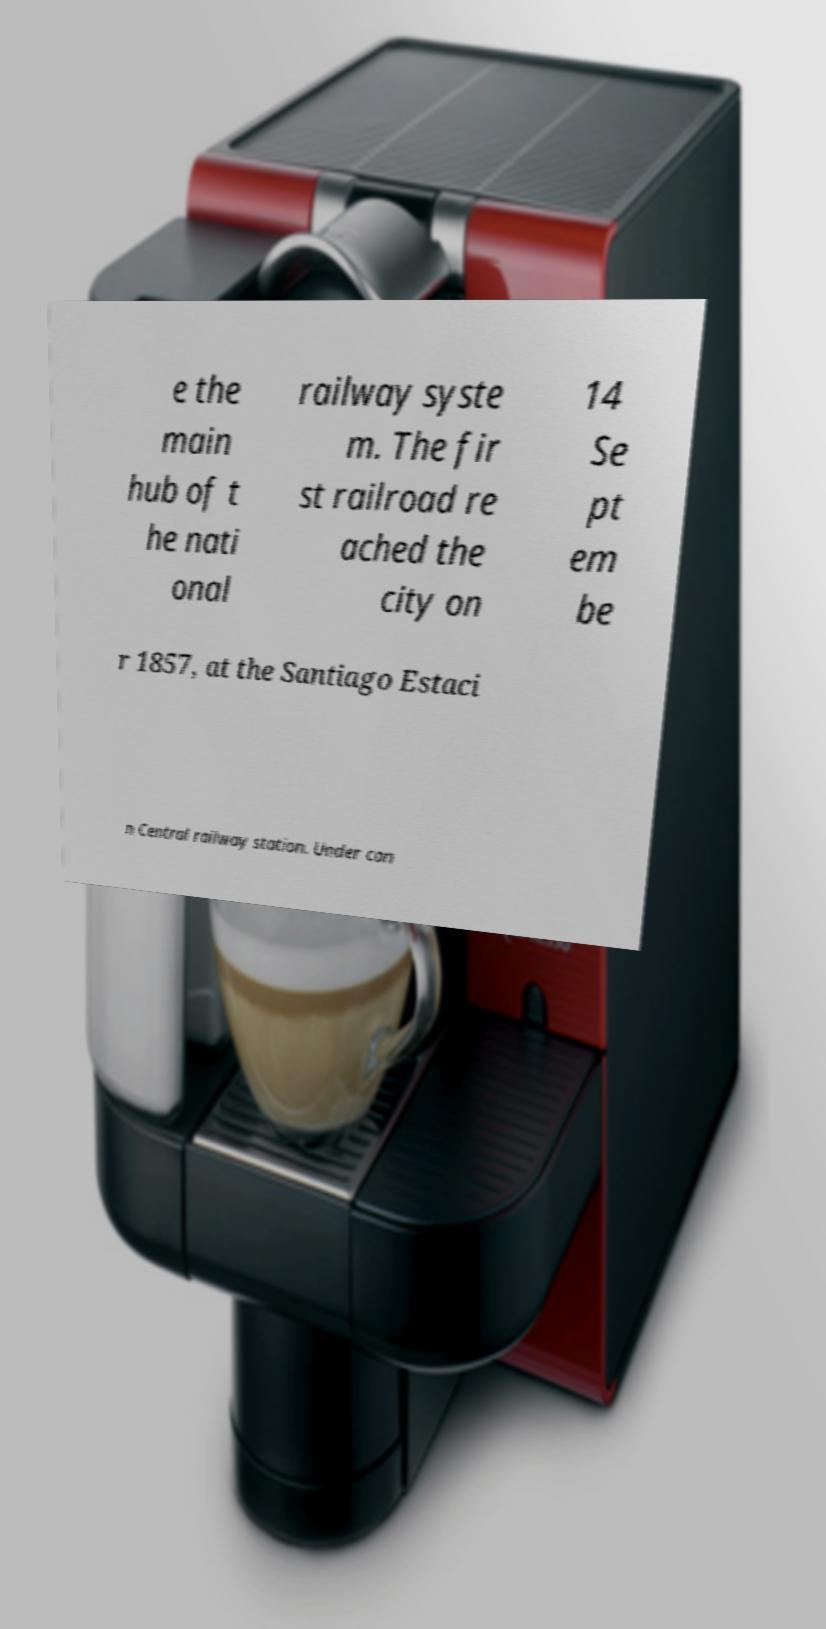For documentation purposes, I need the text within this image transcribed. Could you provide that? e the main hub of t he nati onal railway syste m. The fir st railroad re ached the city on 14 Se pt em be r 1857, at the Santiago Estaci n Central railway station. Under con 